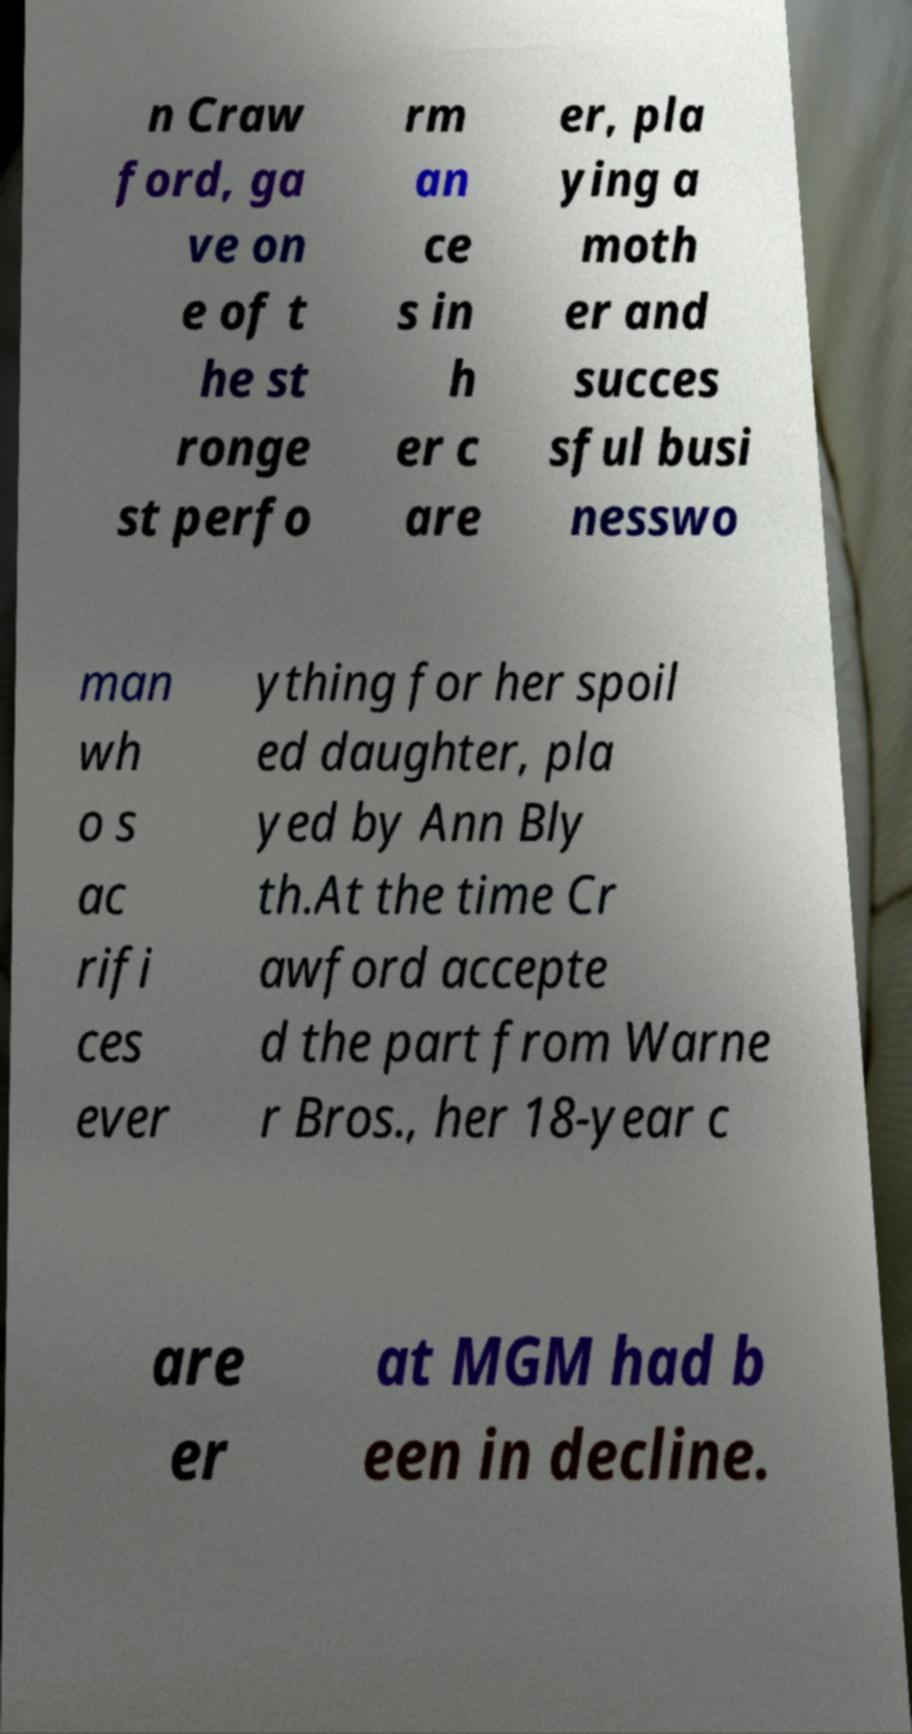Can you accurately transcribe the text from the provided image for me? n Craw ford, ga ve on e of t he st ronge st perfo rm an ce s in h er c are er, pla ying a moth er and succes sful busi nesswo man wh o s ac rifi ces ever ything for her spoil ed daughter, pla yed by Ann Bly th.At the time Cr awford accepte d the part from Warne r Bros., her 18-year c are er at MGM had b een in decline. 